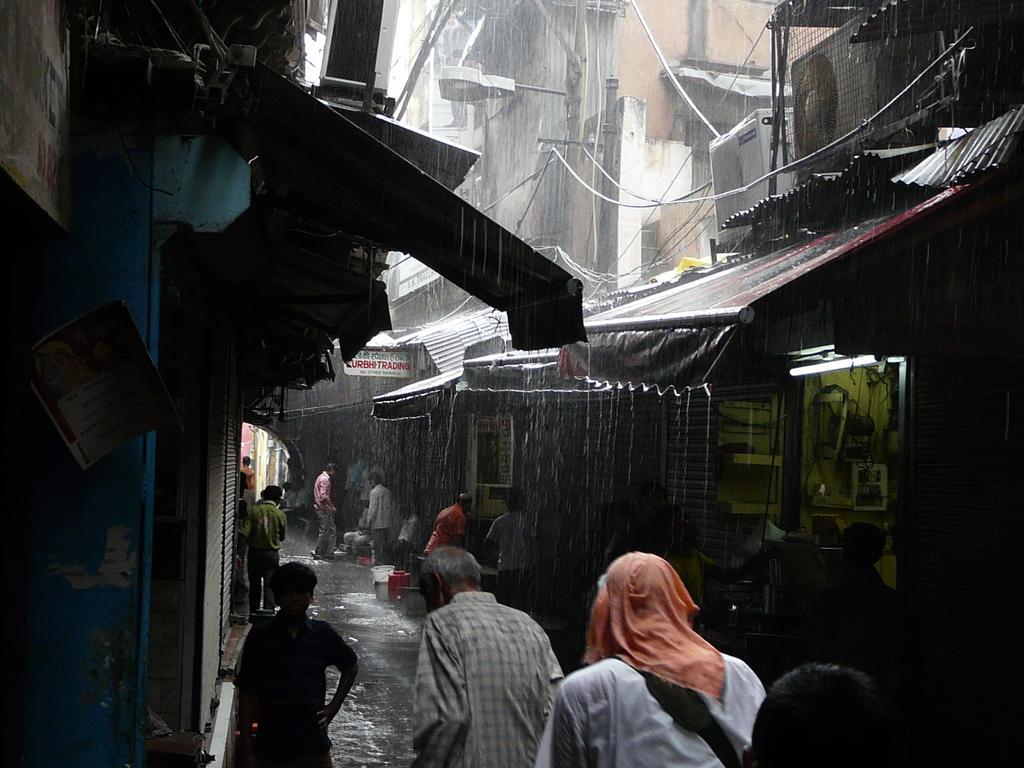Could you give a brief overview of what you see in this image? In this image we can see a few people, shops, street light, electrical poles, cable wires, electronic objects, some written text on the board, water. 